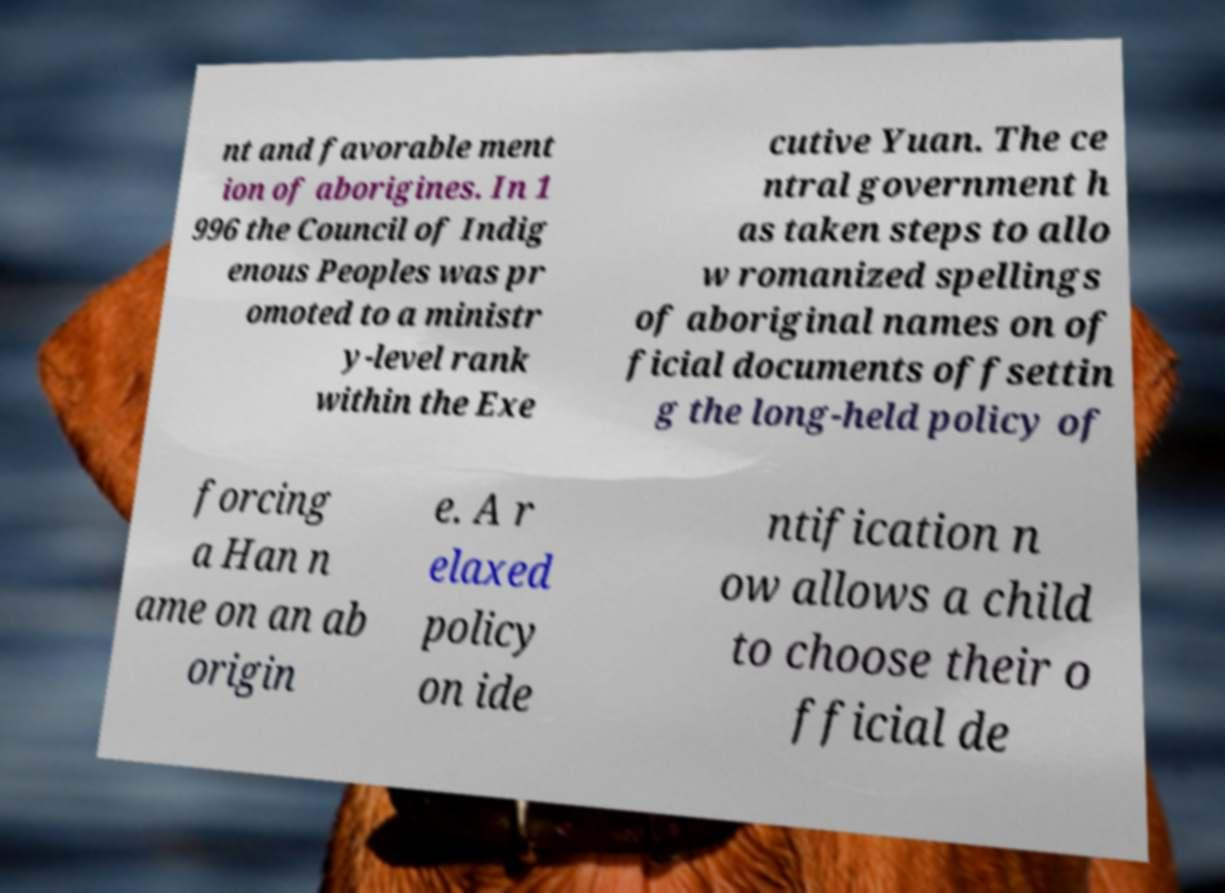For documentation purposes, I need the text within this image transcribed. Could you provide that? nt and favorable ment ion of aborigines. In 1 996 the Council of Indig enous Peoples was pr omoted to a ministr y-level rank within the Exe cutive Yuan. The ce ntral government h as taken steps to allo w romanized spellings of aboriginal names on of ficial documents offsettin g the long-held policy of forcing a Han n ame on an ab origin e. A r elaxed policy on ide ntification n ow allows a child to choose their o fficial de 